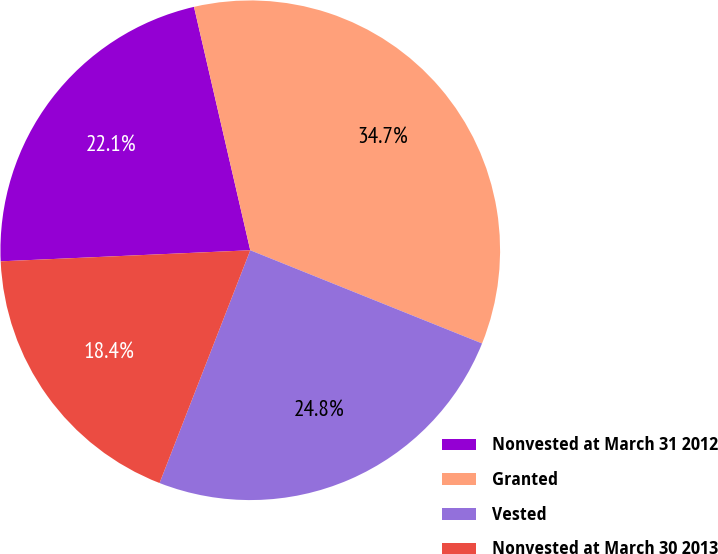Convert chart. <chart><loc_0><loc_0><loc_500><loc_500><pie_chart><fcel>Nonvested at March 31 2012<fcel>Granted<fcel>Vested<fcel>Nonvested at March 30 2013<nl><fcel>22.09%<fcel>34.7%<fcel>24.83%<fcel>18.38%<nl></chart> 